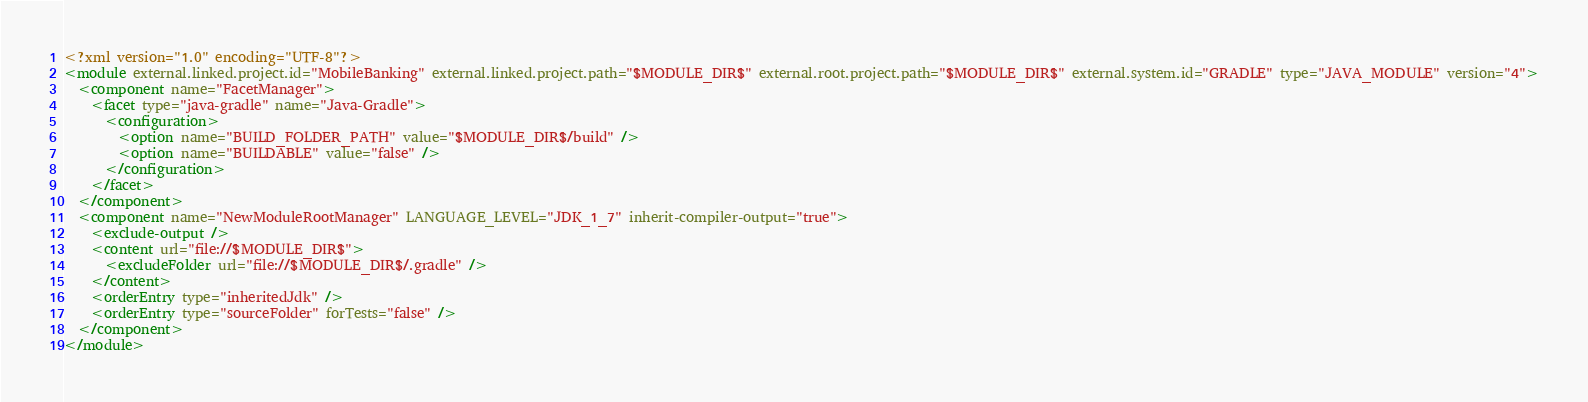<code> <loc_0><loc_0><loc_500><loc_500><_XML_><?xml version="1.0" encoding="UTF-8"?>
<module external.linked.project.id="MobileBanking" external.linked.project.path="$MODULE_DIR$" external.root.project.path="$MODULE_DIR$" external.system.id="GRADLE" type="JAVA_MODULE" version="4">
  <component name="FacetManager">
    <facet type="java-gradle" name="Java-Gradle">
      <configuration>
        <option name="BUILD_FOLDER_PATH" value="$MODULE_DIR$/build" />
        <option name="BUILDABLE" value="false" />
      </configuration>
    </facet>
  </component>
  <component name="NewModuleRootManager" LANGUAGE_LEVEL="JDK_1_7" inherit-compiler-output="true">
    <exclude-output />
    <content url="file://$MODULE_DIR$">
      <excludeFolder url="file://$MODULE_DIR$/.gradle" />
    </content>
    <orderEntry type="inheritedJdk" />
    <orderEntry type="sourceFolder" forTests="false" />
  </component>
</module></code> 